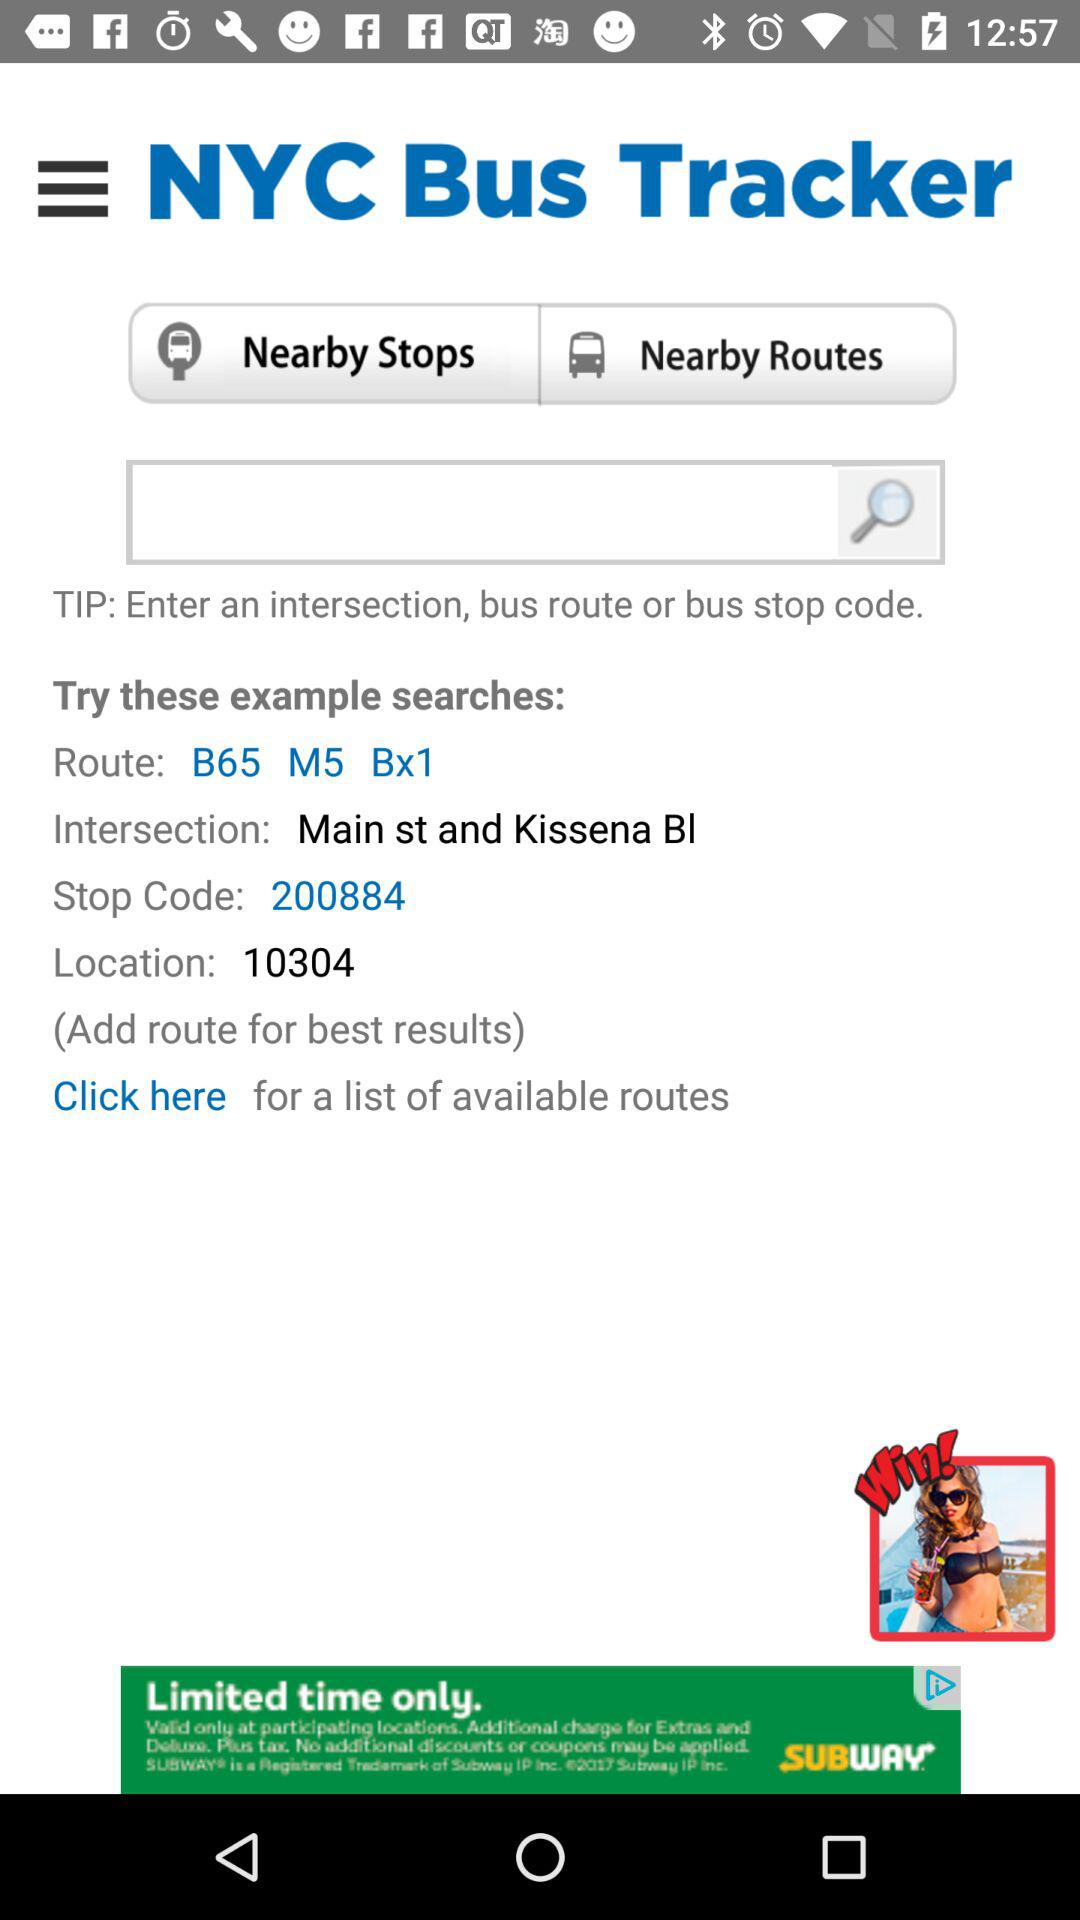What is the example of a route? The examples of routes are "B65", "M5" and "Bx1". 